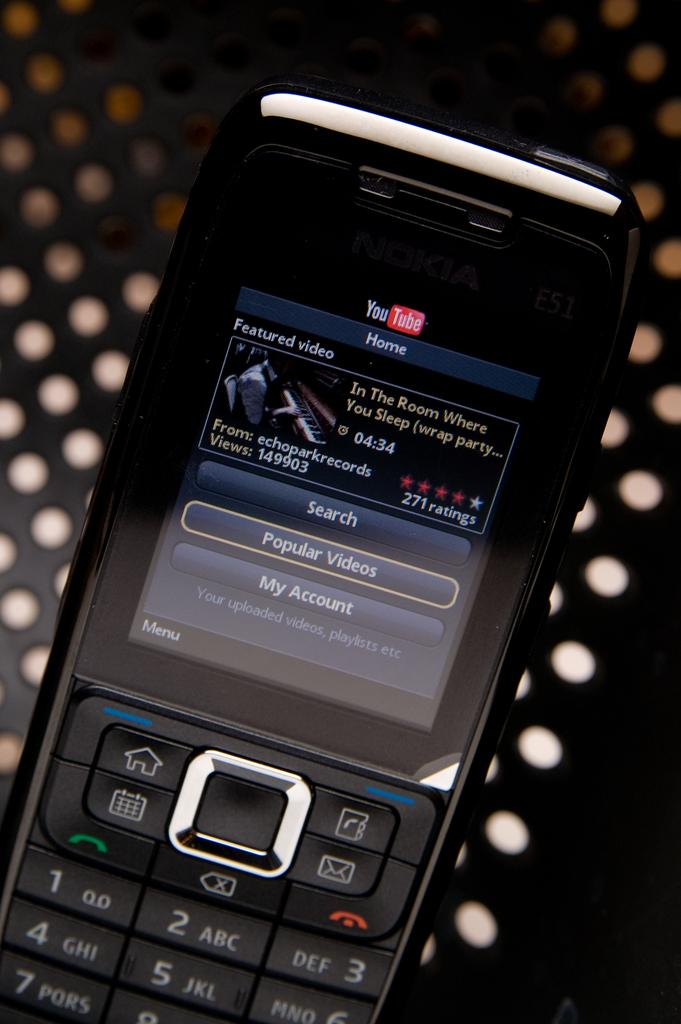<image>
Share a concise interpretation of the image provided. A black phone has a YouTube video pulled up of Echo Park Records "In The Room Where You Sleep". 